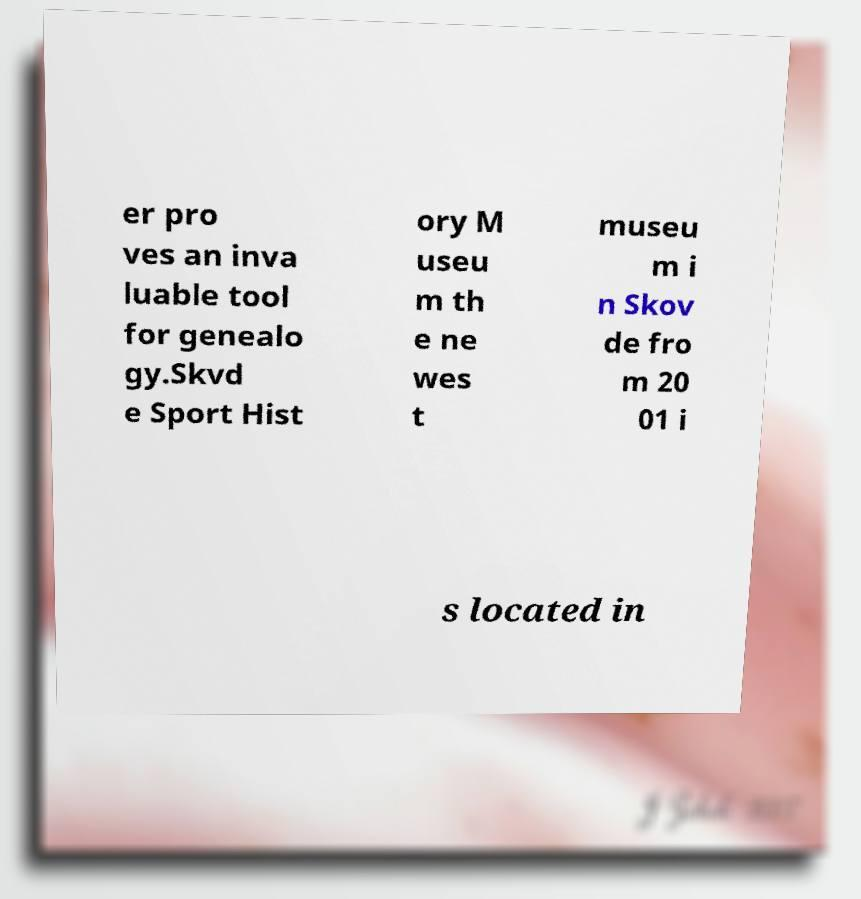Can you accurately transcribe the text from the provided image for me? er pro ves an inva luable tool for genealo gy.Skvd e Sport Hist ory M useu m th e ne wes t museu m i n Skov de fro m 20 01 i s located in 